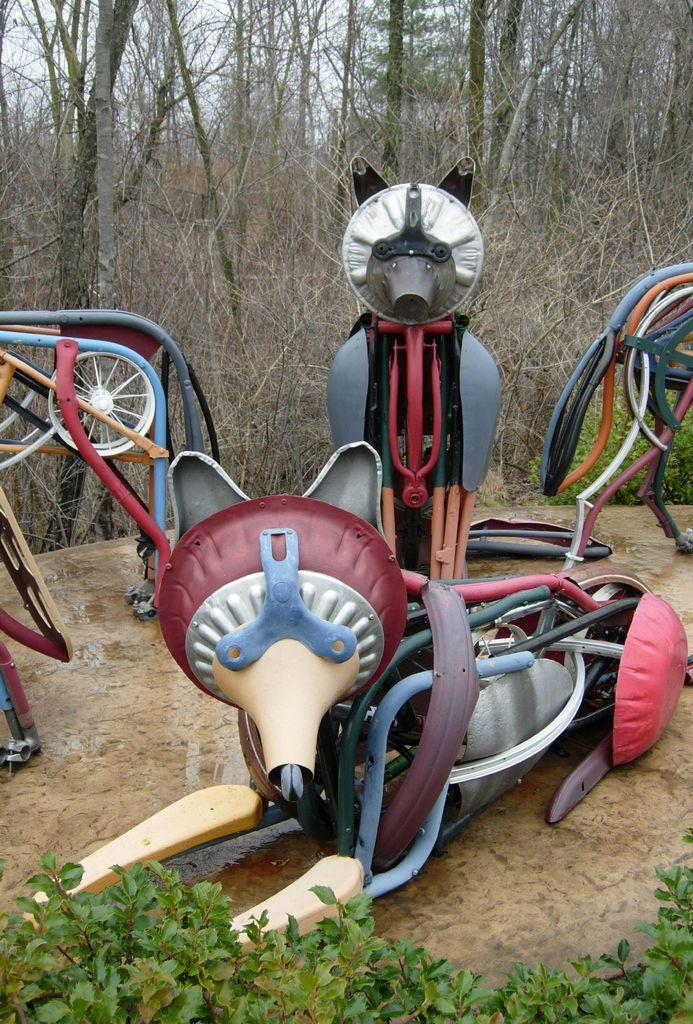What can be observed about the colors in the image? There are colorful things in the image. What type of leaves can be seen in the image? Green color leaves are visible in the image. What is present in the background of the image? There are multiple trees in the background of the image. What type of jelly is being used to protest in the image? There is no protest or jelly present in the image. 